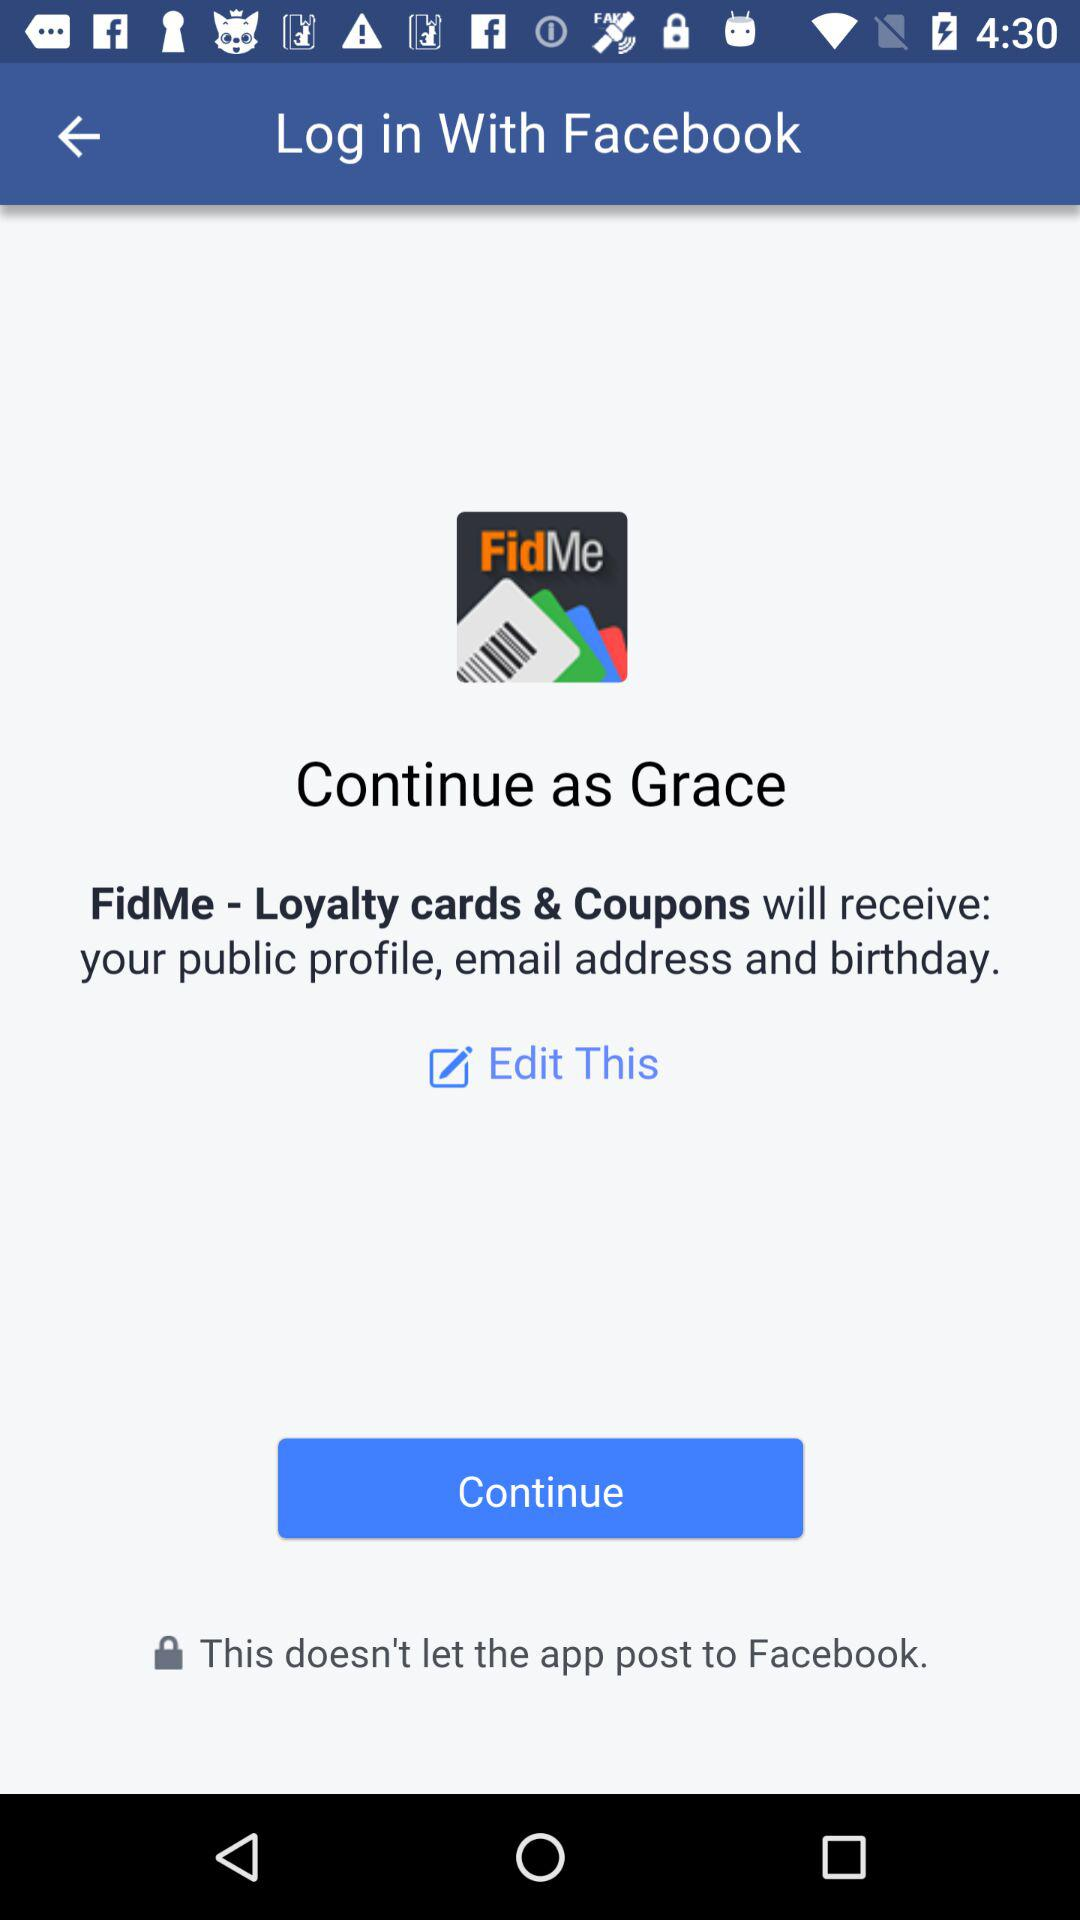Which application are we accessing? You are accessing the application "FidMe - Loyalty cards & Coupons". 